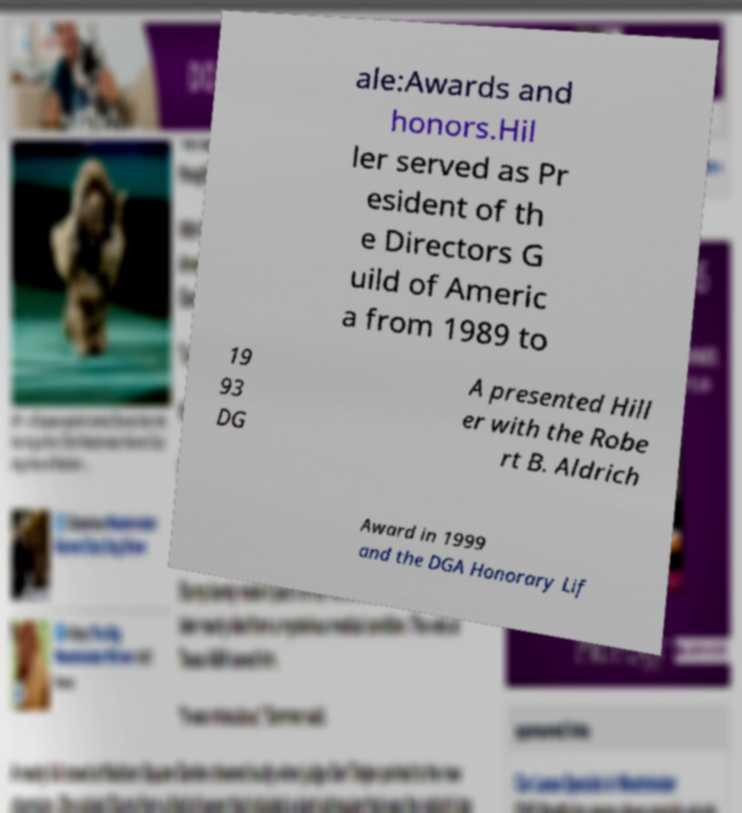Could you extract and type out the text from this image? ale:Awards and honors.Hil ler served as Pr esident of th e Directors G uild of Americ a from 1989 to 19 93 DG A presented Hill er with the Robe rt B. Aldrich Award in 1999 and the DGA Honorary Lif 